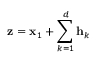<formula> <loc_0><loc_0><loc_500><loc_500>{ z } = { x } _ { 1 } + \sum _ { k = 1 } ^ { d } { h } _ { k }</formula> 